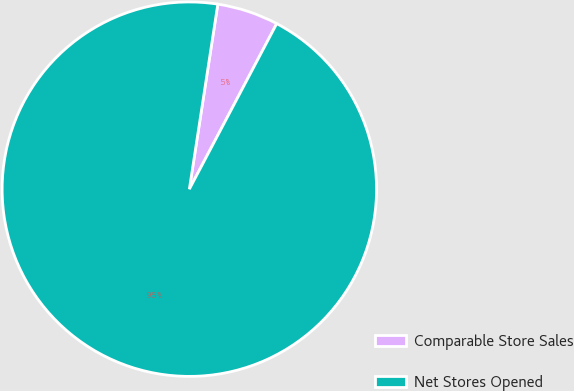Convert chart to OTSL. <chart><loc_0><loc_0><loc_500><loc_500><pie_chart><fcel>Comparable Store Sales<fcel>Net Stores Opened<nl><fcel>5.3%<fcel>94.7%<nl></chart> 